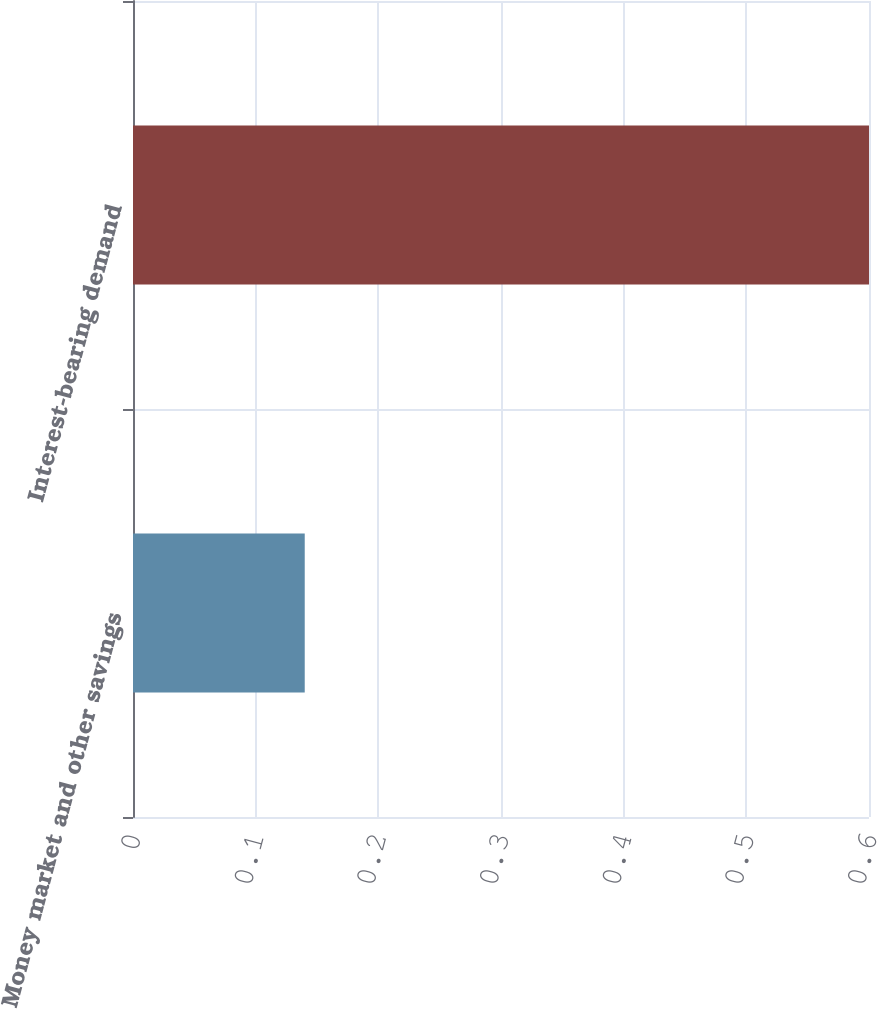Convert chart to OTSL. <chart><loc_0><loc_0><loc_500><loc_500><bar_chart><fcel>Money market and other savings<fcel>Interest-bearing demand<nl><fcel>0.14<fcel>0.6<nl></chart> 